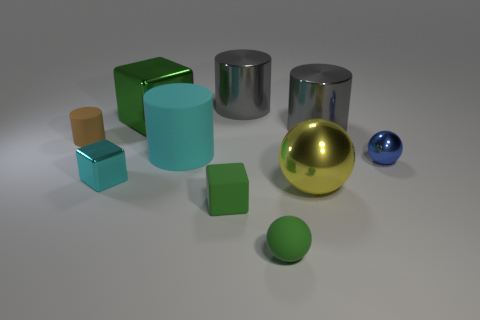There is another block that is the same color as the small rubber cube; what material is it?
Ensure brevity in your answer.  Metal. Is there a small object of the same color as the big metal block?
Your answer should be very brief. Yes. How many big cubes are the same color as the tiny matte block?
Offer a very short reply. 1. There is a large matte thing; is its color the same as the shiny thing that is in front of the tiny cyan block?
Keep it short and to the point. No. What number of objects are blue objects or objects behind the small cylinder?
Provide a succinct answer. 4. What size is the green matte thing left of the small rubber object in front of the small rubber block?
Offer a very short reply. Small. Are there the same number of large yellow objects that are behind the large rubber object and big objects that are behind the yellow metallic sphere?
Offer a very short reply. No. Are there any rubber things that are behind the small ball behind the small green ball?
Offer a terse response. Yes. What shape is the yellow object that is made of the same material as the blue object?
Ensure brevity in your answer.  Sphere. Is there any other thing that has the same color as the large matte cylinder?
Give a very brief answer. Yes. 